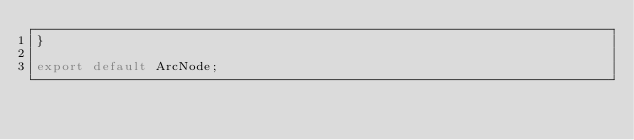<code> <loc_0><loc_0><loc_500><loc_500><_JavaScript_>}

export default ArcNode;
</code> 